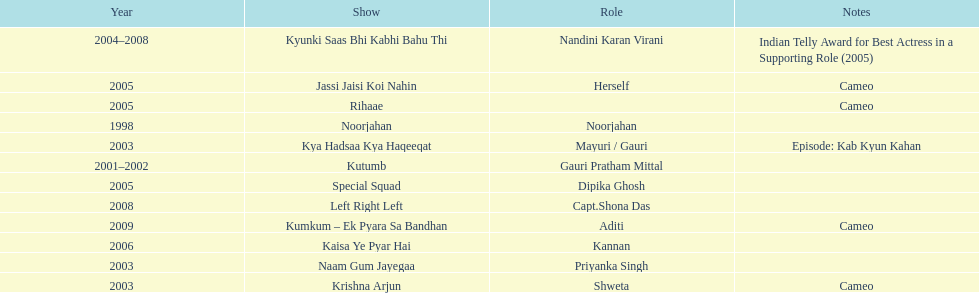The shows with at most 1 cameo Krishna Arjun, Rihaae, Jassi Jaisi Koi Nahin, Kumkum - Ek Pyara Sa Bandhan. 